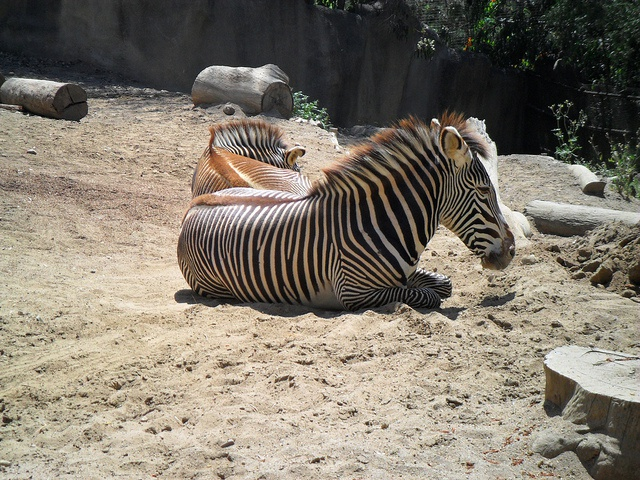Describe the objects in this image and their specific colors. I can see zebra in black and gray tones and zebra in black, gray, lightgray, and darkgray tones in this image. 